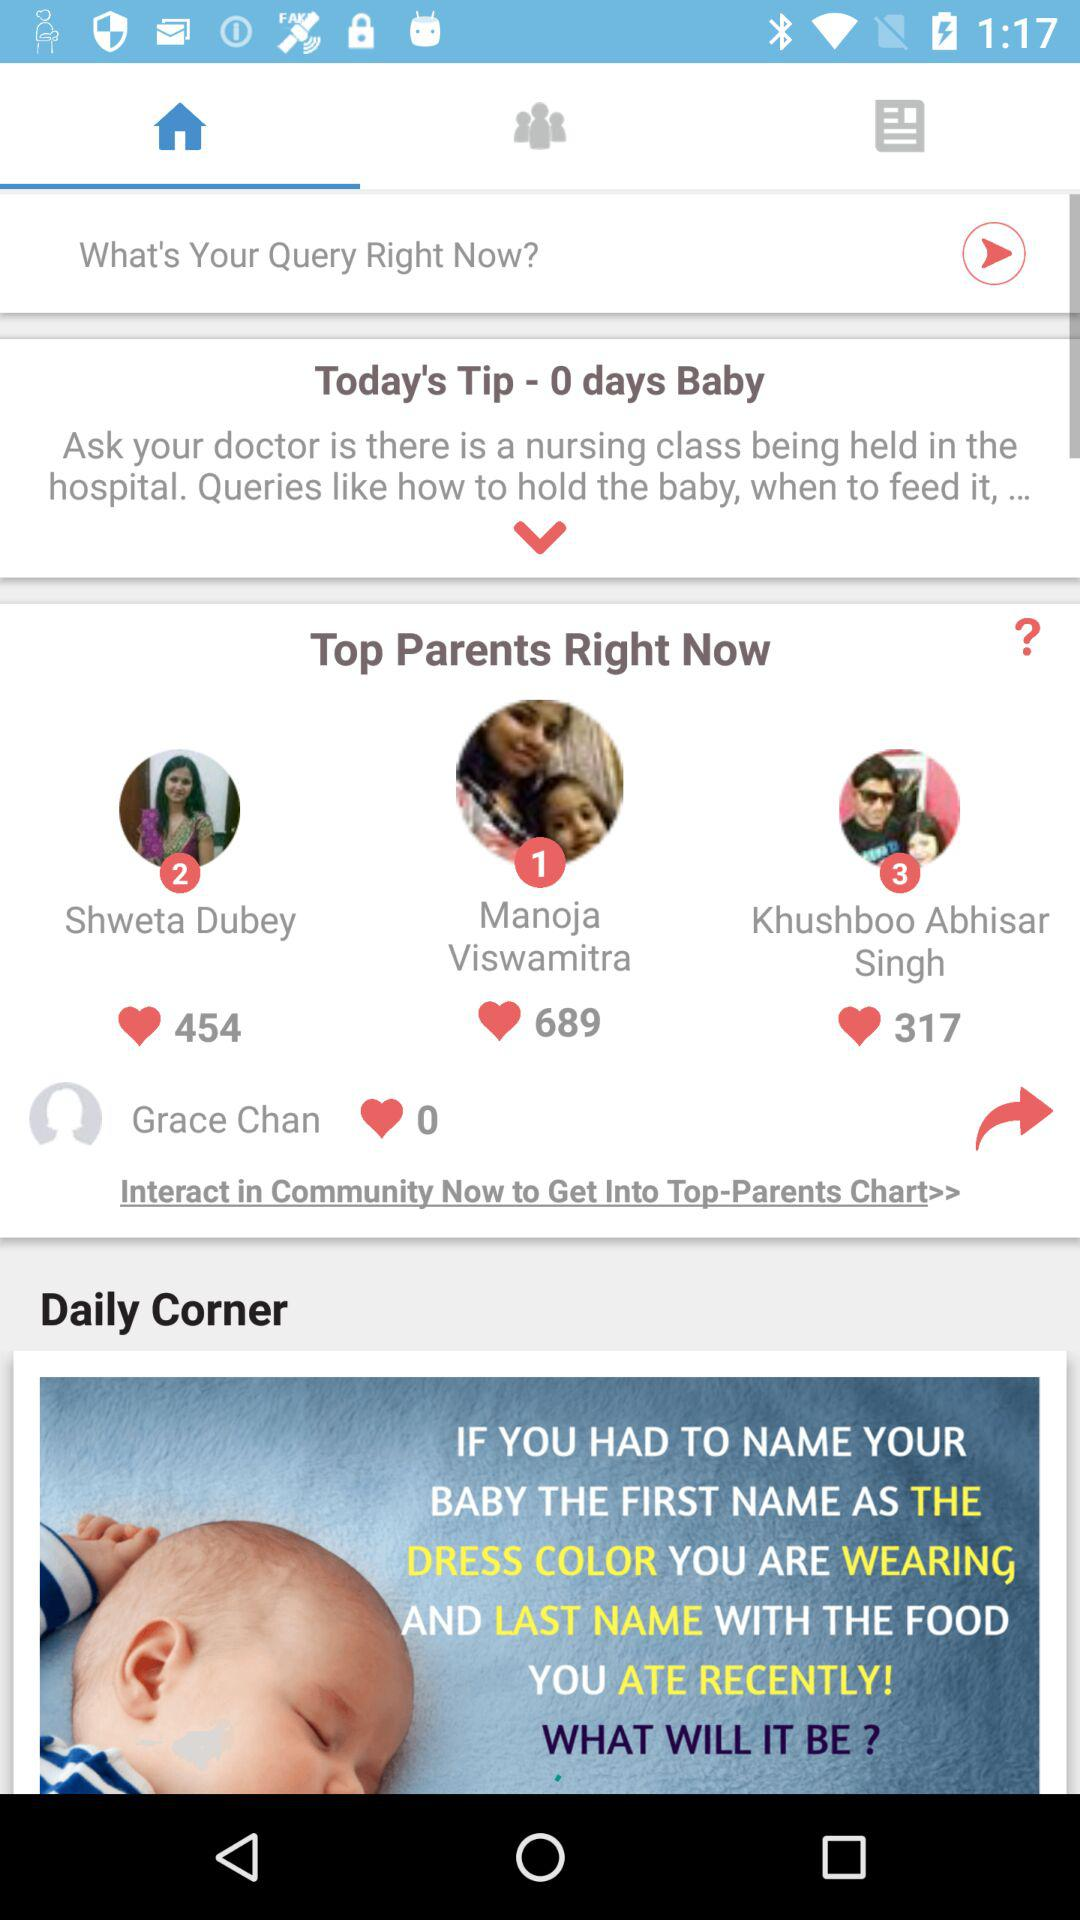Which tab has been selected? The tab that has been selected is "Home". 